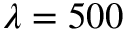Convert formula to latex. <formula><loc_0><loc_0><loc_500><loc_500>\lambda = 5 0 0</formula> 